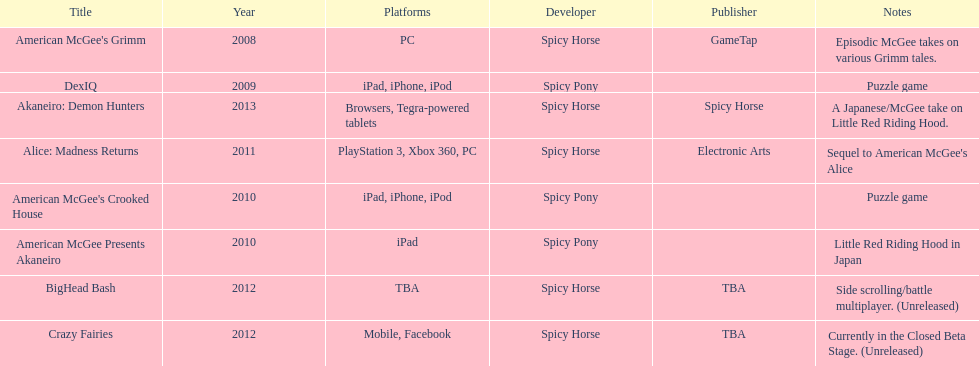What was the last game created by spicy horse Akaneiro: Demon Hunters. Parse the full table. {'header': ['Title', 'Year', 'Platforms', 'Developer', 'Publisher', 'Notes'], 'rows': [["American McGee's Grimm", '2008', 'PC', 'Spicy Horse', 'GameTap', 'Episodic McGee takes on various Grimm tales.'], ['DexIQ', '2009', 'iPad, iPhone, iPod', 'Spicy Pony', '', 'Puzzle game'], ['Akaneiro: Demon Hunters', '2013', 'Browsers, Tegra-powered tablets', 'Spicy Horse', 'Spicy Horse', 'A Japanese/McGee take on Little Red Riding Hood.'], ['Alice: Madness Returns', '2011', 'PlayStation 3, Xbox 360, PC', 'Spicy Horse', 'Electronic Arts', "Sequel to American McGee's Alice"], ["American McGee's Crooked House", '2010', 'iPad, iPhone, iPod', 'Spicy Pony', '', 'Puzzle game'], ['American McGee Presents Akaneiro', '2010', 'iPad', 'Spicy Pony', '', 'Little Red Riding Hood in Japan'], ['BigHead Bash', '2012', 'TBA', 'Spicy Horse', 'TBA', 'Side scrolling/battle multiplayer. (Unreleased)'], ['Crazy Fairies', '2012', 'Mobile, Facebook', 'Spicy Horse', 'TBA', 'Currently in the Closed Beta Stage. (Unreleased)']]} 